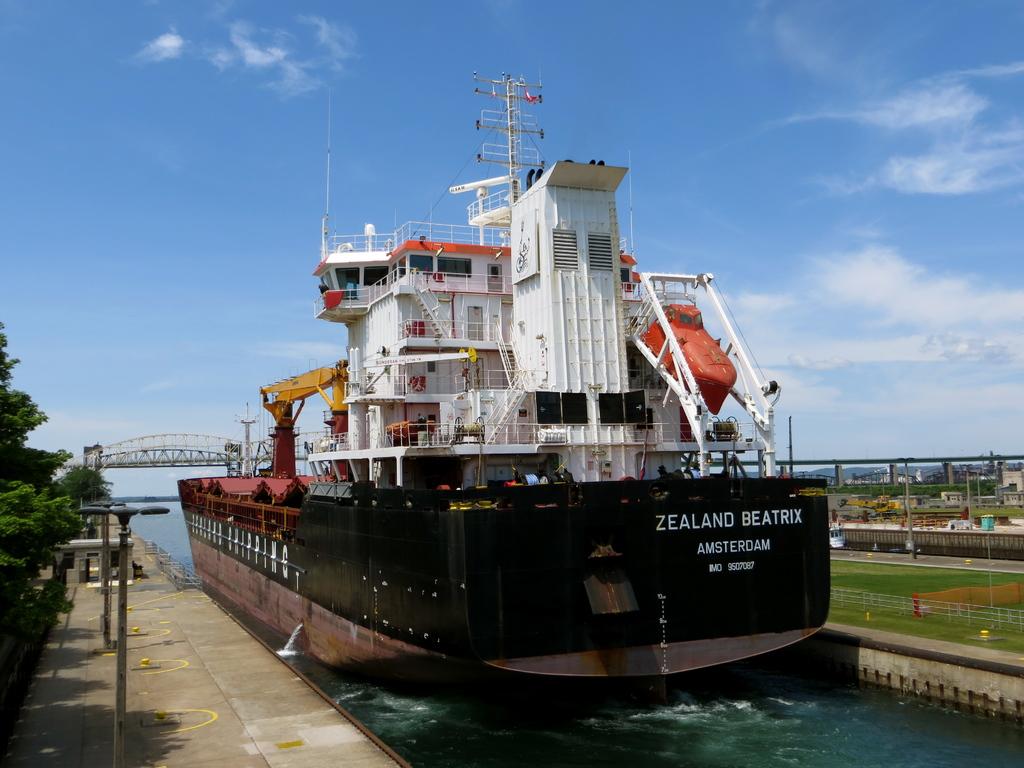Where is the ship from?
Ensure brevity in your answer.  Amsterdam. Where is this ship from?
Your response must be concise. Amsterdam. 